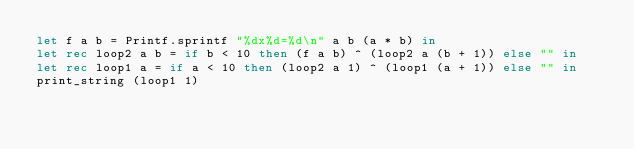Convert code to text. <code><loc_0><loc_0><loc_500><loc_500><_OCaml_>let f a b = Printf.sprintf "%dx%d=%d\n" a b (a * b) in
let rec loop2 a b = if b < 10 then (f a b) ^ (loop2 a (b + 1)) else "" in
let rec loop1 a = if a < 10 then (loop2 a 1) ^ (loop1 (a + 1)) else "" in
print_string (loop1 1)</code> 